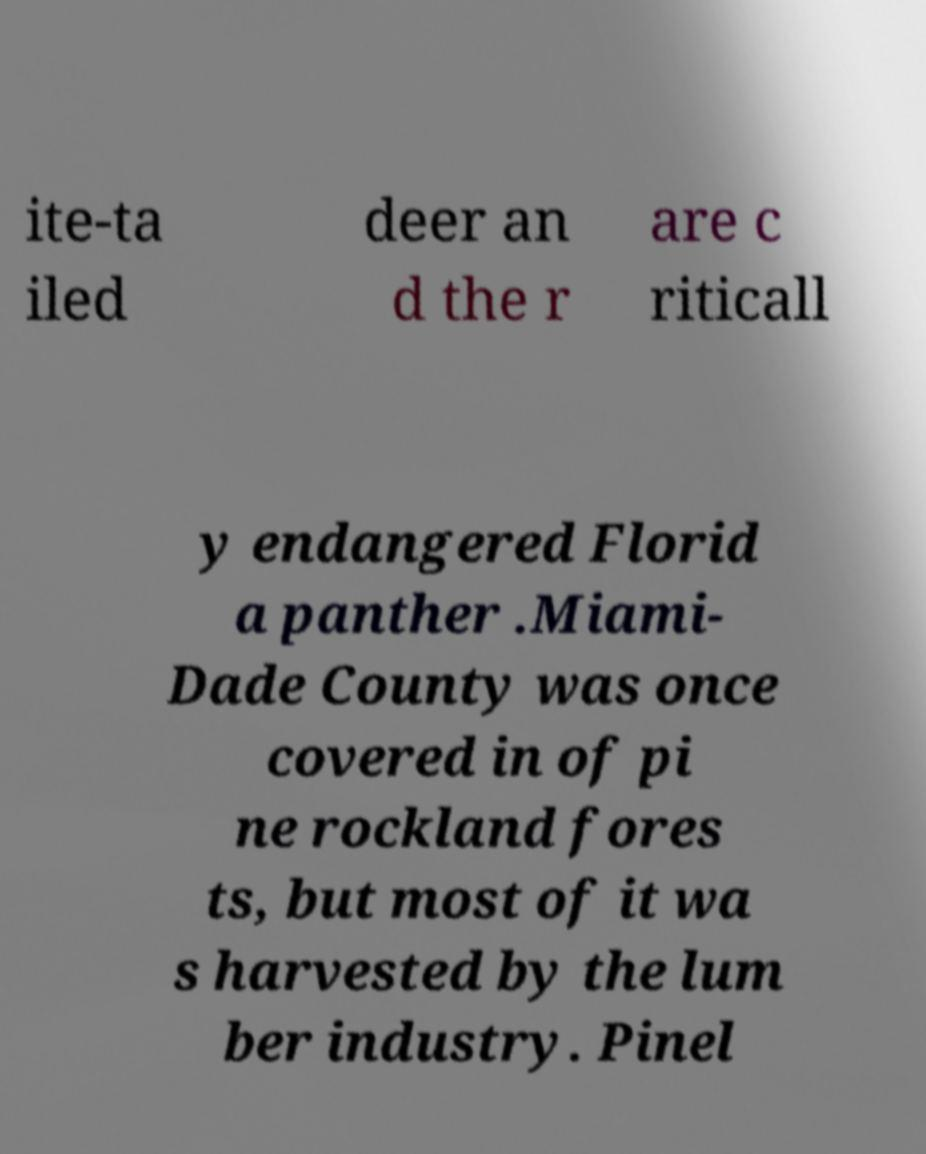Could you assist in decoding the text presented in this image and type it out clearly? ite-ta iled deer an d the r are c riticall y endangered Florid a panther .Miami- Dade County was once covered in of pi ne rockland fores ts, but most of it wa s harvested by the lum ber industry. Pinel 